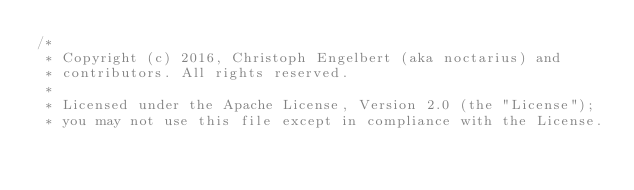Convert code to text. <code><loc_0><loc_0><loc_500><loc_500><_Java_>/*
 * Copyright (c) 2016, Christoph Engelbert (aka noctarius) and
 * contributors. All rights reserved.
 *
 * Licensed under the Apache License, Version 2.0 (the "License");
 * you may not use this file except in compliance with the License.</code> 